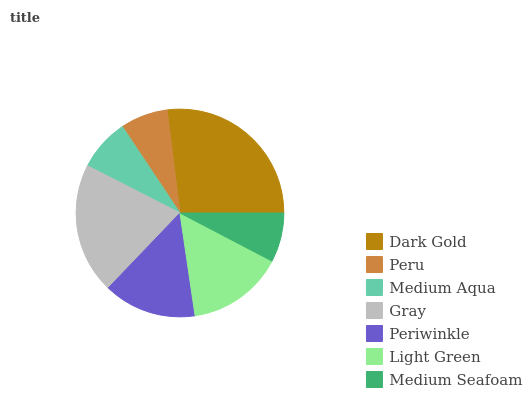Is Peru the minimum?
Answer yes or no. Yes. Is Dark Gold the maximum?
Answer yes or no. Yes. Is Medium Aqua the minimum?
Answer yes or no. No. Is Medium Aqua the maximum?
Answer yes or no. No. Is Medium Aqua greater than Peru?
Answer yes or no. Yes. Is Peru less than Medium Aqua?
Answer yes or no. Yes. Is Peru greater than Medium Aqua?
Answer yes or no. No. Is Medium Aqua less than Peru?
Answer yes or no. No. Is Periwinkle the high median?
Answer yes or no. Yes. Is Periwinkle the low median?
Answer yes or no. Yes. Is Medium Aqua the high median?
Answer yes or no. No. Is Light Green the low median?
Answer yes or no. No. 